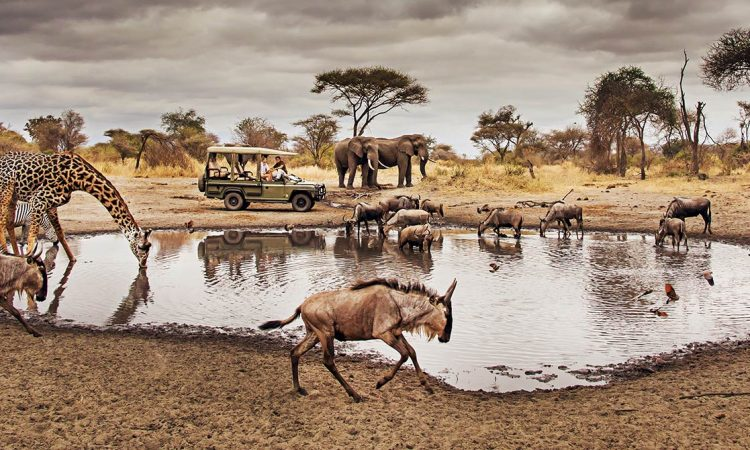Imagine you are writing a journal entry as one of the tourists in the safari vehicle. What would you write? Day 5 - Serengeti Safari

Today was nothing short of magical. As we drove along the dusty trails of Serengeti National Park, we stumbled upon a watering hole—a bustling hub of life. Our guide whispered in excitement; this was a rare sight. The scene was almost surreal. A graceful giraffe, seemingly curious about our presence, walked towards our vehicle, its enormous frame casting a shadow over us. The wildebeests were busy quenching their thirst, their reflections dancing on the water's surface under the overcast sky. In the background, two majestic elephants stood tall, embodying the true essence of the African wilderness. We watched in silent awe, our cameras capturing what words couldn't. The sky was dramatic with thick clouds, adding a layer of mystique to the already enchanting setting. This experience has left an indelible mark on me, a reminder of the beauty and resilience of nature. I feel incredibly privileged to witness such a moment, one that will forever be etched in my memory. What if this scene could talk? What do you think it would say? If this scene could talk, it might say: 'Welcome to the Serengeti, where the dance of life and survival unfolds each day. Here, around this vital watering hole, we gather—sharing resources and navigating our existence side by side. The giraffe curiously inspects its surroundings, the wildebeests drink cautiously, and the elephants display their grandeur and wisdom. We are a testament to nature's balance, resilience, and beauty. Cherish this moment, humans, for you are witnessing a timeless ritual in the heart of the African wilderness. Remember to respect and protect the delicate web of life we share.' 